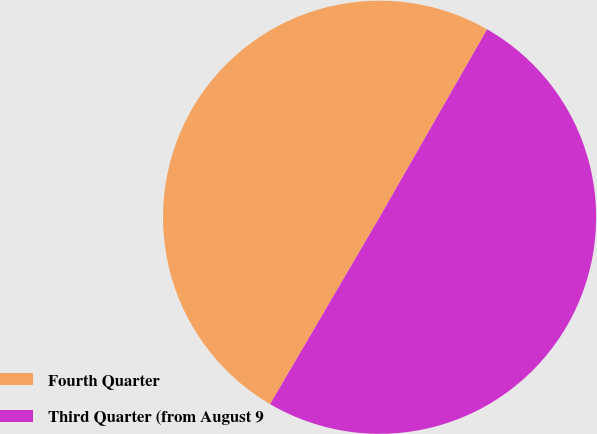Convert chart. <chart><loc_0><loc_0><loc_500><loc_500><pie_chart><fcel>Fourth Quarter<fcel>Third Quarter (from August 9<nl><fcel>49.84%<fcel>50.16%<nl></chart> 